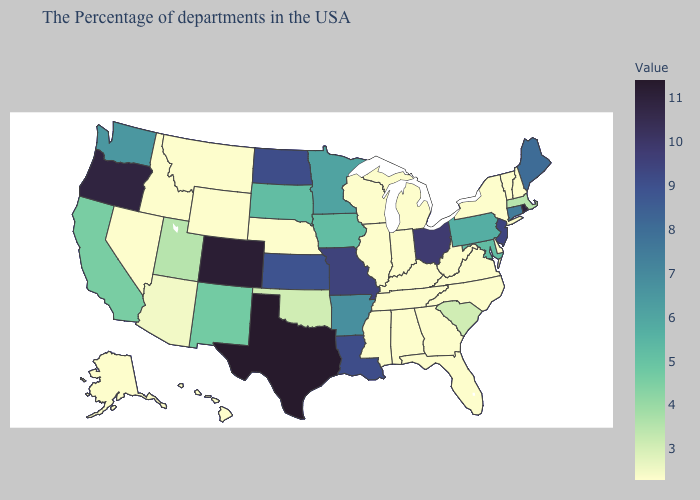Does Iowa have the lowest value in the MidWest?
Answer briefly. No. Does Delaware have a lower value than Oregon?
Concise answer only. Yes. Among the states that border North Dakota , does Montana have the highest value?
Be succinct. No. Does California have a lower value than Virginia?
Write a very short answer. No. Does Minnesota have the lowest value in the MidWest?
Concise answer only. No. Does North Dakota have the highest value in the MidWest?
Be succinct. No. Does Texas have the highest value in the USA?
Answer briefly. Yes. 